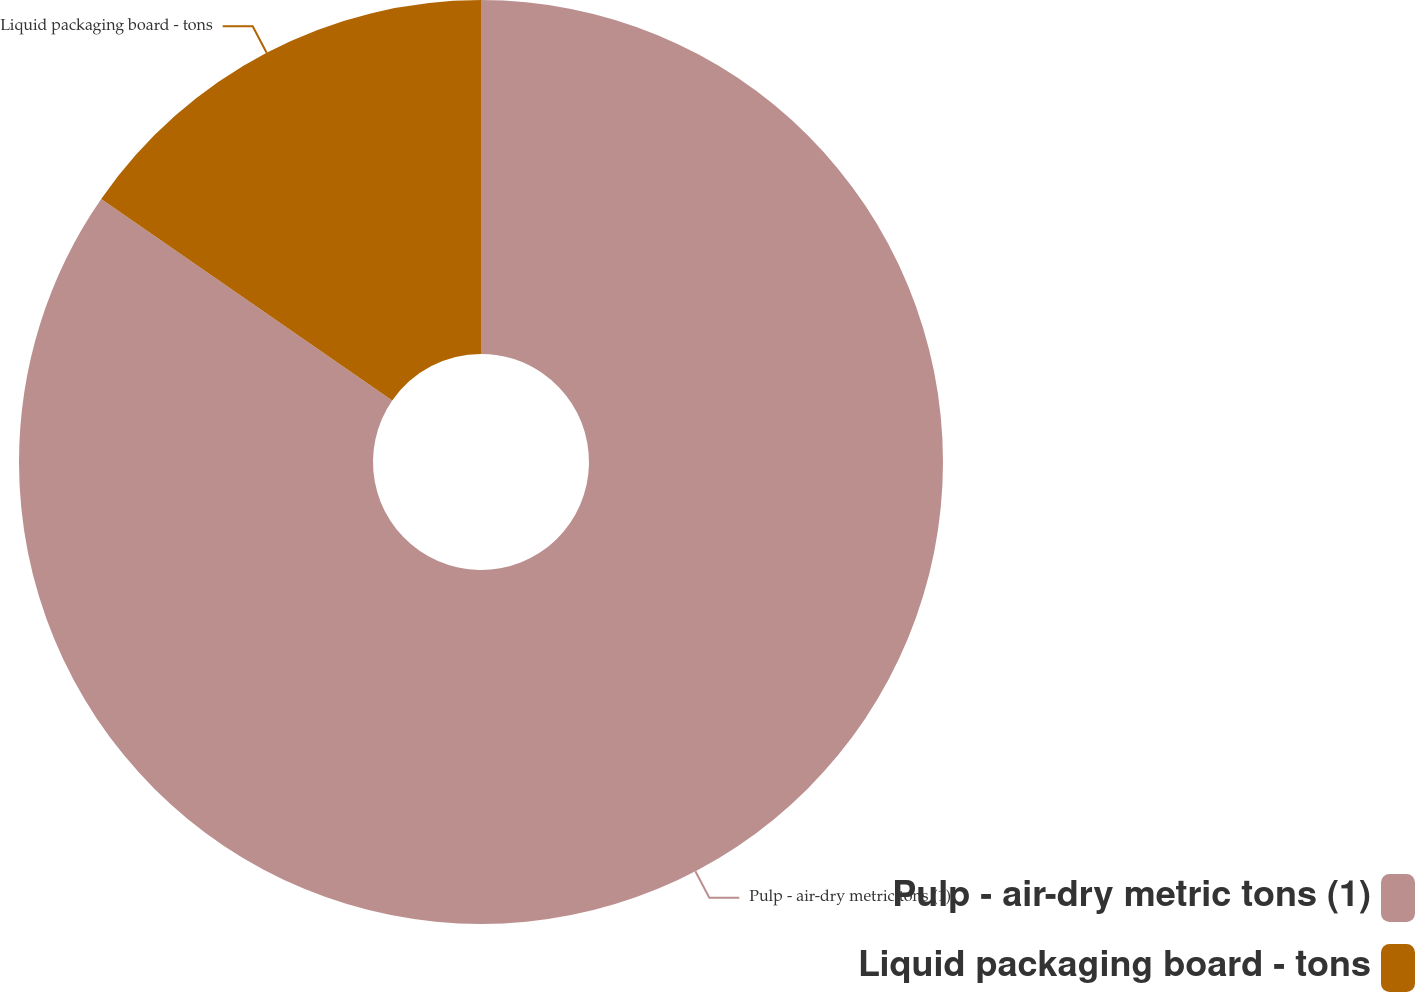Convert chart. <chart><loc_0><loc_0><loc_500><loc_500><pie_chart><fcel>Pulp - air-dry metric tons (1)<fcel>Liquid packaging board - tons<nl><fcel>84.64%<fcel>15.36%<nl></chart> 